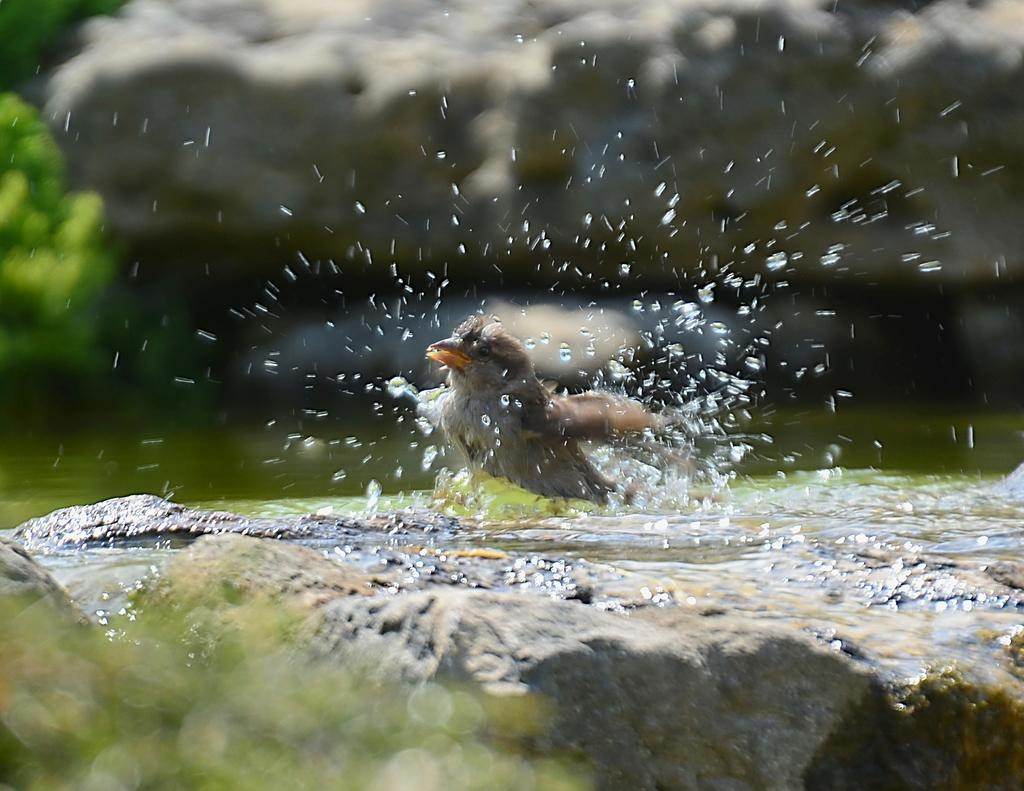What is the main subject in the center of the image? There is a bird in the center of the image. What can be seen in the background of the image? There is water visible in the image. What type of natural features are present in the image? There are rocks in the image. What type of vegetation is on the left side of the image? There are plants on the left side of the image. How many ladybugs are performing addition on the rocks in the image? There are no ladybugs or any indication of addition present in the image. 